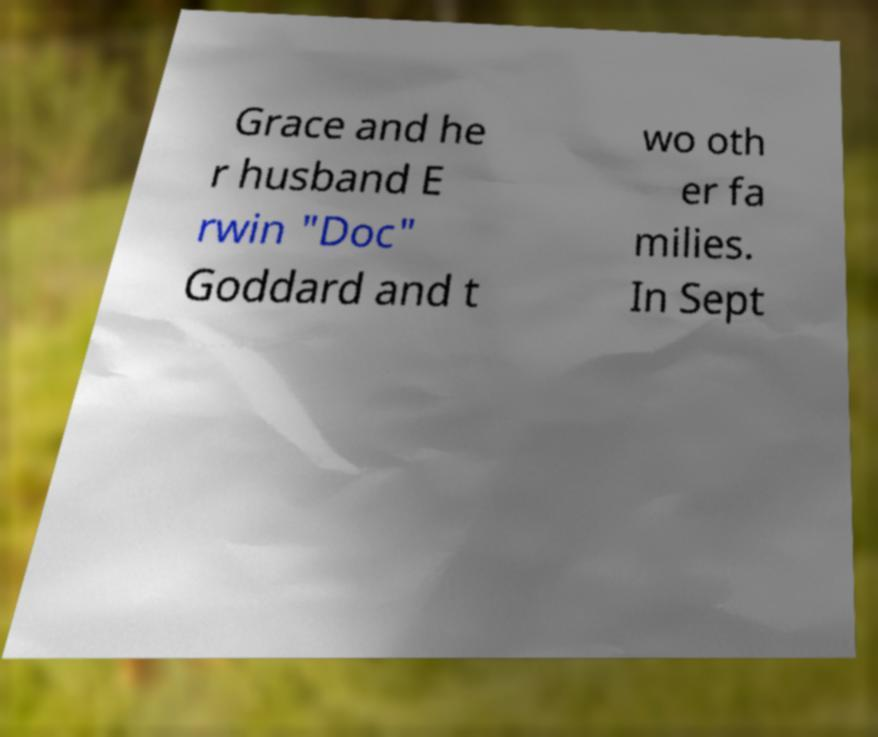Please read and relay the text visible in this image. What does it say? Grace and he r husband E rwin "Doc" Goddard and t wo oth er fa milies. In Sept 